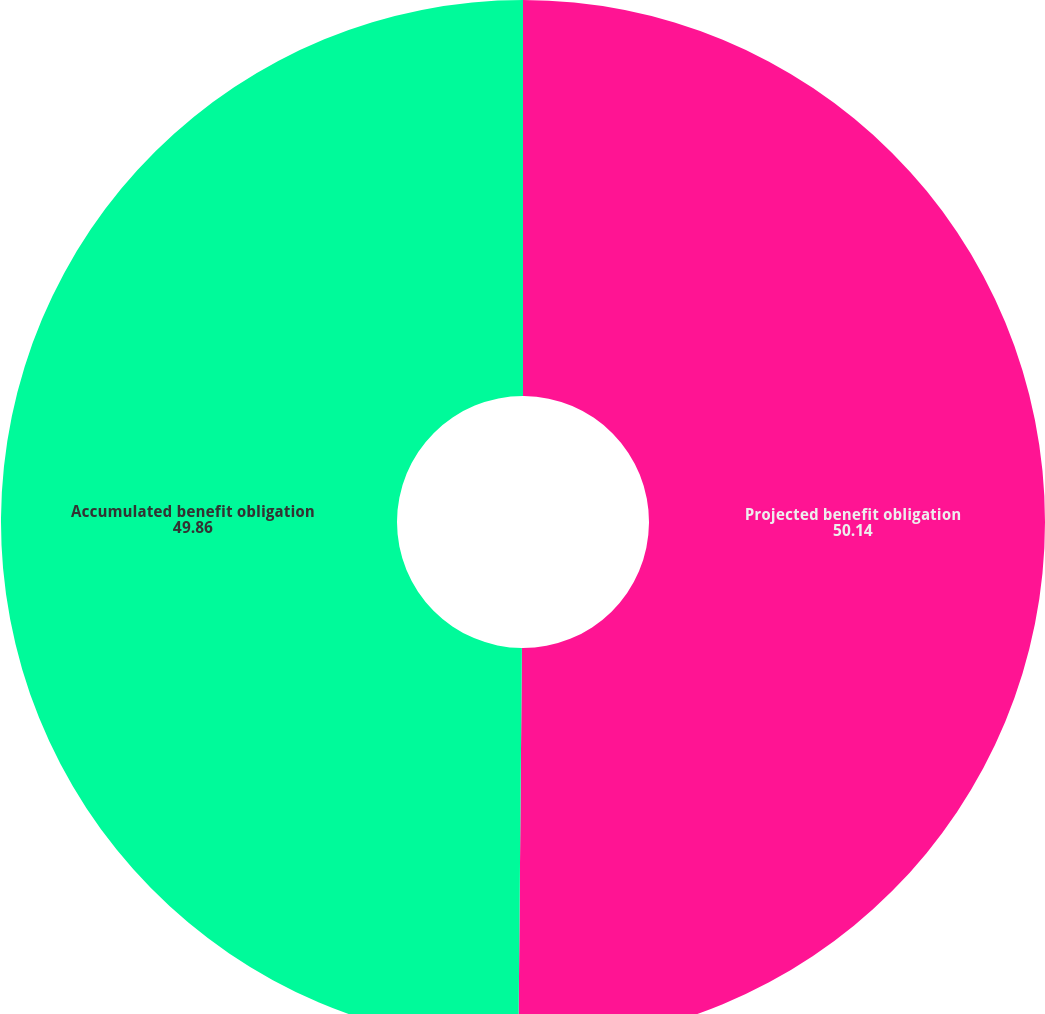<chart> <loc_0><loc_0><loc_500><loc_500><pie_chart><fcel>Projected benefit obligation<fcel>Accumulated benefit obligation<nl><fcel>50.14%<fcel>49.86%<nl></chart> 